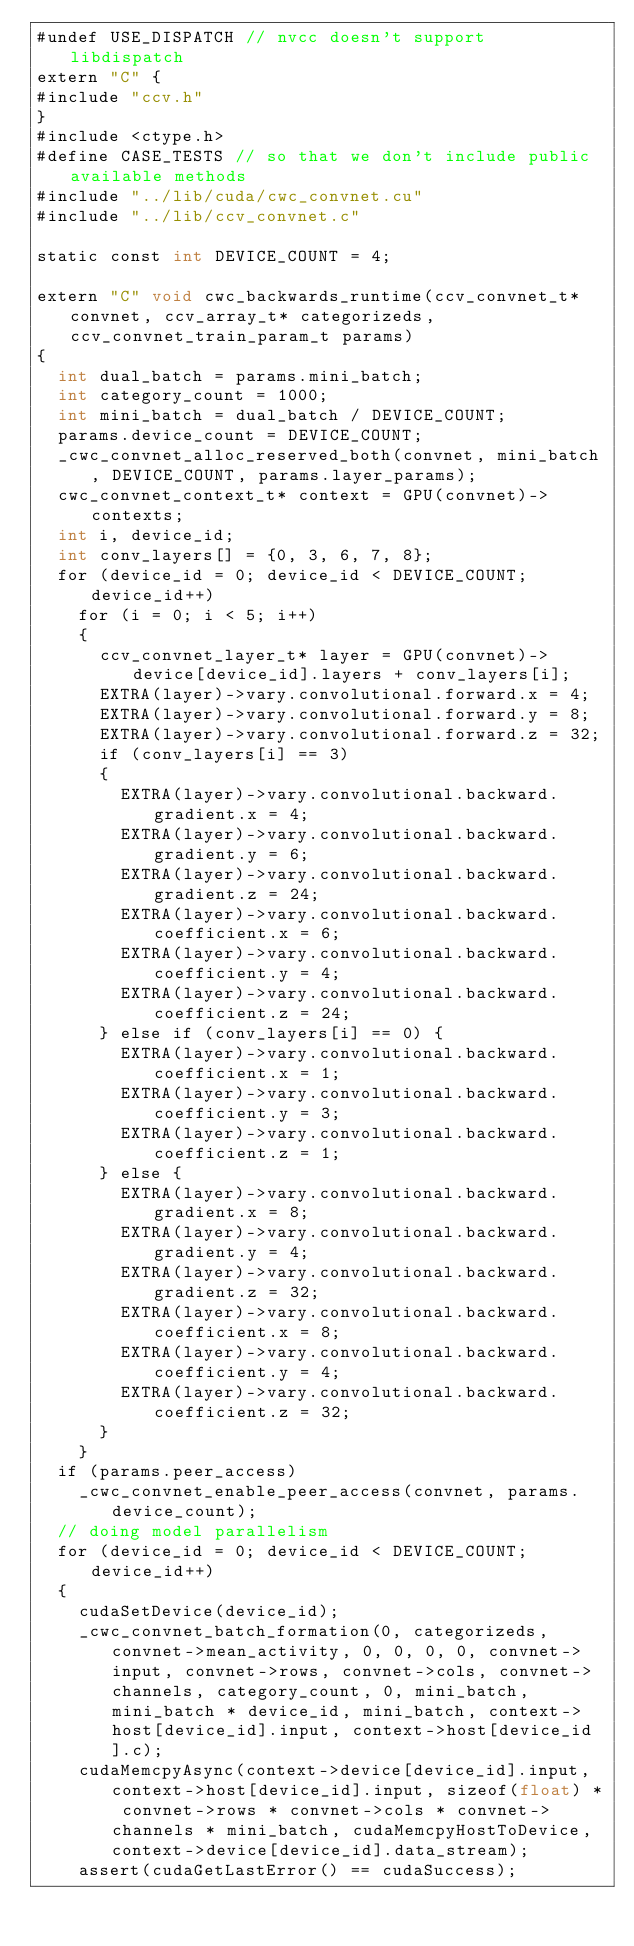Convert code to text. <code><loc_0><loc_0><loc_500><loc_500><_Cuda_>#undef USE_DISPATCH // nvcc doesn't support libdispatch
extern "C" {
#include "ccv.h"
}
#include <ctype.h>
#define CASE_TESTS // so that we don't include public available methods
#include "../lib/cuda/cwc_convnet.cu"
#include "../lib/ccv_convnet.c"

static const int DEVICE_COUNT = 4;

extern "C" void cwc_backwards_runtime(ccv_convnet_t* convnet, ccv_array_t* categorizeds, ccv_convnet_train_param_t params)
{
	int dual_batch = params.mini_batch;
	int category_count = 1000;
	int mini_batch = dual_batch / DEVICE_COUNT;
	params.device_count = DEVICE_COUNT;
	_cwc_convnet_alloc_reserved_both(convnet, mini_batch, DEVICE_COUNT, params.layer_params);
	cwc_convnet_context_t* context = GPU(convnet)->contexts;
	int i, device_id;
	int conv_layers[] = {0, 3, 6, 7, 8};
	for (device_id = 0; device_id < DEVICE_COUNT; device_id++)
		for (i = 0; i < 5; i++)
		{
			ccv_convnet_layer_t* layer = GPU(convnet)->device[device_id].layers + conv_layers[i];
			EXTRA(layer)->vary.convolutional.forward.x = 4;
			EXTRA(layer)->vary.convolutional.forward.y = 8;
			EXTRA(layer)->vary.convolutional.forward.z = 32;
			if (conv_layers[i] == 3)
			{
				EXTRA(layer)->vary.convolutional.backward.gradient.x = 4;
				EXTRA(layer)->vary.convolutional.backward.gradient.y = 6;
				EXTRA(layer)->vary.convolutional.backward.gradient.z = 24;
				EXTRA(layer)->vary.convolutional.backward.coefficient.x = 6;
				EXTRA(layer)->vary.convolutional.backward.coefficient.y = 4;
				EXTRA(layer)->vary.convolutional.backward.coefficient.z = 24;
			} else if (conv_layers[i] == 0) {
				EXTRA(layer)->vary.convolutional.backward.coefficient.x = 1;
				EXTRA(layer)->vary.convolutional.backward.coefficient.y = 3;
				EXTRA(layer)->vary.convolutional.backward.coefficient.z = 1;
			} else {
				EXTRA(layer)->vary.convolutional.backward.gradient.x = 8;
				EXTRA(layer)->vary.convolutional.backward.gradient.y = 4;
				EXTRA(layer)->vary.convolutional.backward.gradient.z = 32;
				EXTRA(layer)->vary.convolutional.backward.coefficient.x = 8;
				EXTRA(layer)->vary.convolutional.backward.coefficient.y = 4;
				EXTRA(layer)->vary.convolutional.backward.coefficient.z = 32;
			}
		}
	if (params.peer_access)
		_cwc_convnet_enable_peer_access(convnet, params.device_count);
	// doing model parallelism
	for (device_id = 0; device_id < DEVICE_COUNT; device_id++)
	{
		cudaSetDevice(device_id);
		_cwc_convnet_batch_formation(0, categorizeds, convnet->mean_activity, 0, 0, 0, 0, convnet->input, convnet->rows, convnet->cols, convnet->channels, category_count, 0, mini_batch, mini_batch * device_id, mini_batch, context->host[device_id].input, context->host[device_id].c);
		cudaMemcpyAsync(context->device[device_id].input, context->host[device_id].input, sizeof(float) * convnet->rows * convnet->cols * convnet->channels * mini_batch, cudaMemcpyHostToDevice, context->device[device_id].data_stream);
		assert(cudaGetLastError() == cudaSuccess);</code> 